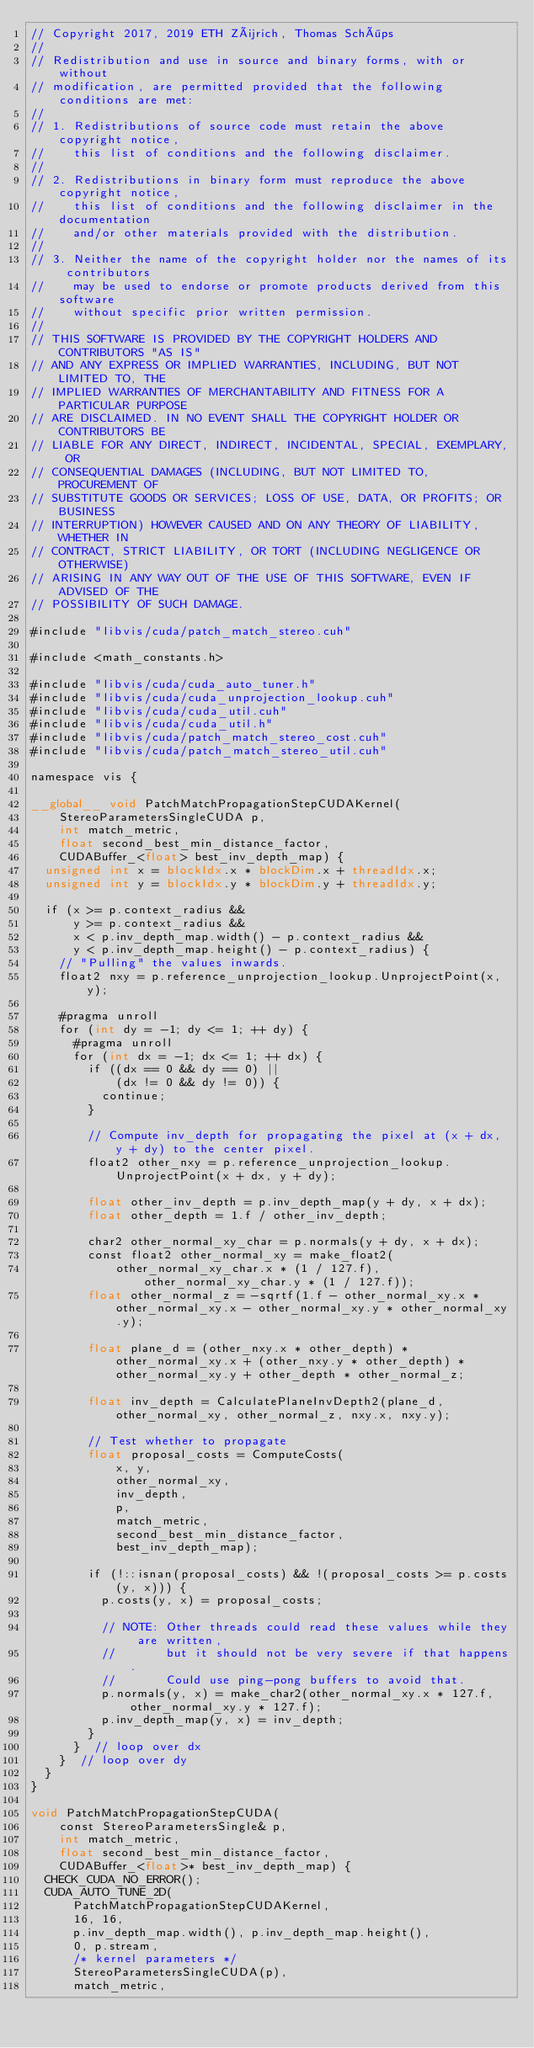<code> <loc_0><loc_0><loc_500><loc_500><_Cuda_>// Copyright 2017, 2019 ETH Zürich, Thomas Schöps
//
// Redistribution and use in source and binary forms, with or without
// modification, are permitted provided that the following conditions are met:
//
// 1. Redistributions of source code must retain the above copyright notice,
//    this list of conditions and the following disclaimer.
//
// 2. Redistributions in binary form must reproduce the above copyright notice,
//    this list of conditions and the following disclaimer in the documentation
//    and/or other materials provided with the distribution.
//
// 3. Neither the name of the copyright holder nor the names of its contributors
//    may be used to endorse or promote products derived from this software
//    without specific prior written permission.
//
// THIS SOFTWARE IS PROVIDED BY THE COPYRIGHT HOLDERS AND CONTRIBUTORS "AS IS"
// AND ANY EXPRESS OR IMPLIED WARRANTIES, INCLUDING, BUT NOT LIMITED TO, THE
// IMPLIED WARRANTIES OF MERCHANTABILITY AND FITNESS FOR A PARTICULAR PURPOSE
// ARE DISCLAIMED. IN NO EVENT SHALL THE COPYRIGHT HOLDER OR CONTRIBUTORS BE
// LIABLE FOR ANY DIRECT, INDIRECT, INCIDENTAL, SPECIAL, EXEMPLARY, OR
// CONSEQUENTIAL DAMAGES (INCLUDING, BUT NOT LIMITED TO, PROCUREMENT OF
// SUBSTITUTE GOODS OR SERVICES; LOSS OF USE, DATA, OR PROFITS; OR BUSINESS
// INTERRUPTION) HOWEVER CAUSED AND ON ANY THEORY OF LIABILITY, WHETHER IN
// CONTRACT, STRICT LIABILITY, OR TORT (INCLUDING NEGLIGENCE OR OTHERWISE)
// ARISING IN ANY WAY OUT OF THE USE OF THIS SOFTWARE, EVEN IF ADVISED OF THE
// POSSIBILITY OF SUCH DAMAGE.

#include "libvis/cuda/patch_match_stereo.cuh"

#include <math_constants.h>

#include "libvis/cuda/cuda_auto_tuner.h"
#include "libvis/cuda/cuda_unprojection_lookup.cuh"
#include "libvis/cuda/cuda_util.cuh"
#include "libvis/cuda/cuda_util.h"
#include "libvis/cuda/patch_match_stereo_cost.cuh"
#include "libvis/cuda/patch_match_stereo_util.cuh"

namespace vis {

__global__ void PatchMatchPropagationStepCUDAKernel(
    StereoParametersSingleCUDA p,
    int match_metric,
    float second_best_min_distance_factor,
    CUDABuffer_<float> best_inv_depth_map) {
  unsigned int x = blockIdx.x * blockDim.x + threadIdx.x;
  unsigned int y = blockIdx.y * blockDim.y + threadIdx.y;
  
  if (x >= p.context_radius &&
      y >= p.context_radius &&
      x < p.inv_depth_map.width() - p.context_radius &&
      y < p.inv_depth_map.height() - p.context_radius) {
    // "Pulling" the values inwards.
    float2 nxy = p.reference_unprojection_lookup.UnprojectPoint(x, y);
    
    #pragma unroll
    for (int dy = -1; dy <= 1; ++ dy) {
      #pragma unroll
      for (int dx = -1; dx <= 1; ++ dx) {
        if ((dx == 0 && dy == 0) ||
            (dx != 0 && dy != 0)) {
          continue;
        }
        
        // Compute inv_depth for propagating the pixel at (x + dx, y + dy) to the center pixel.
        float2 other_nxy = p.reference_unprojection_lookup.UnprojectPoint(x + dx, y + dy);
        
        float other_inv_depth = p.inv_depth_map(y + dy, x + dx);
        float other_depth = 1.f / other_inv_depth;
        
        char2 other_normal_xy_char = p.normals(y + dy, x + dx);
        const float2 other_normal_xy = make_float2(
            other_normal_xy_char.x * (1 / 127.f), other_normal_xy_char.y * (1 / 127.f));
        float other_normal_z = -sqrtf(1.f - other_normal_xy.x * other_normal_xy.x - other_normal_xy.y * other_normal_xy.y);
        
        float plane_d = (other_nxy.x * other_depth) * other_normal_xy.x + (other_nxy.y * other_depth) * other_normal_xy.y + other_depth * other_normal_z;
        
        float inv_depth = CalculatePlaneInvDepth2(plane_d, other_normal_xy, other_normal_z, nxy.x, nxy.y);
        
        // Test whether to propagate
        float proposal_costs = ComputeCosts(
            x, y,
            other_normal_xy,
            inv_depth,
            p,
            match_metric,
            second_best_min_distance_factor,
            best_inv_depth_map);
        
        if (!::isnan(proposal_costs) && !(proposal_costs >= p.costs(y, x))) {
          p.costs(y, x) = proposal_costs;
          
          // NOTE: Other threads could read these values while they are written,
          //       but it should not be very severe if that happens.
          //       Could use ping-pong buffers to avoid that.
          p.normals(y, x) = make_char2(other_normal_xy.x * 127.f, other_normal_xy.y * 127.f);
          p.inv_depth_map(y, x) = inv_depth;
        }
      }  // loop over dx
    }  // loop over dy
  }
}

void PatchMatchPropagationStepCUDA(
    const StereoParametersSingle& p,
    int match_metric,
    float second_best_min_distance_factor,
    CUDABuffer_<float>* best_inv_depth_map) {
  CHECK_CUDA_NO_ERROR();
  CUDA_AUTO_TUNE_2D(
      PatchMatchPropagationStepCUDAKernel,
      16, 16,
      p.inv_depth_map.width(), p.inv_depth_map.height(),
      0, p.stream,
      /* kernel parameters */
      StereoParametersSingleCUDA(p),
      match_metric,</code> 